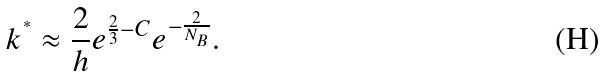<formula> <loc_0><loc_0><loc_500><loc_500>k ^ { ^ { * } } \approx \frac { 2 } { h } e ^ { \frac { 2 } { 3 } - C } e ^ { - \frac { 2 } { N _ { B } } } .</formula> 